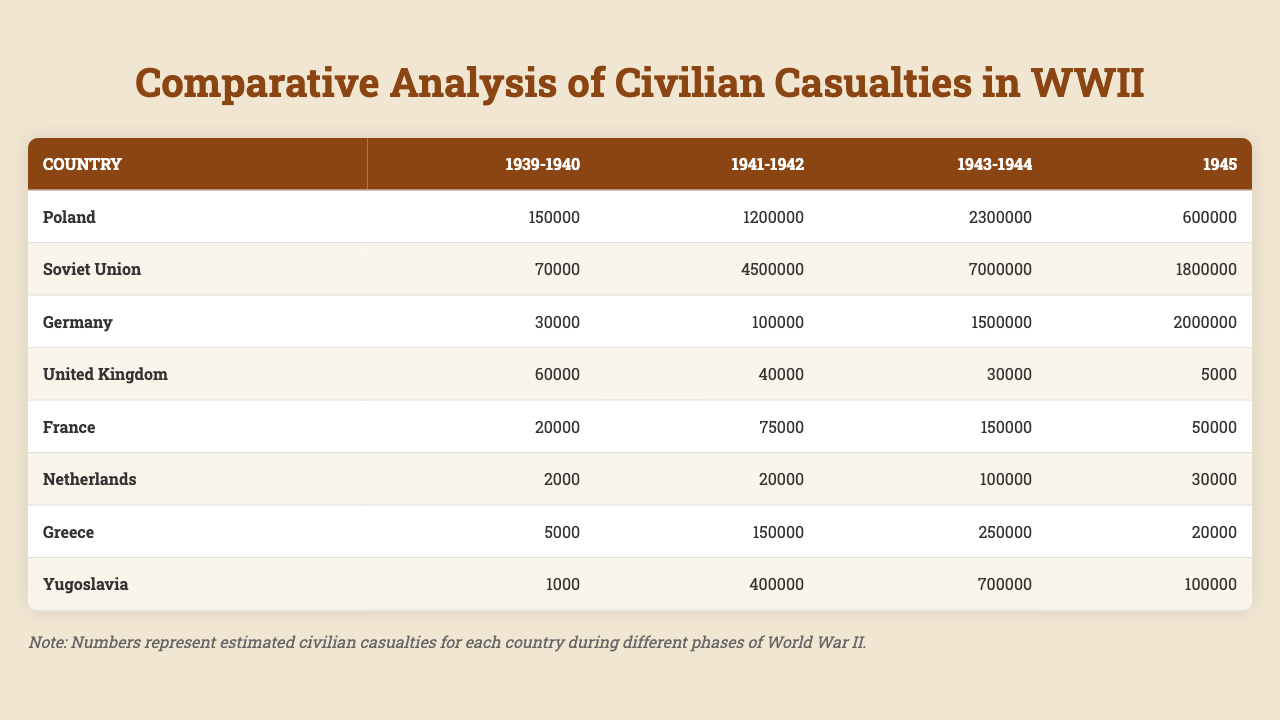What was the total number of civilian casualties in Poland during 1943-1944? The table shows that Poland had 2,300,000 civilian casualties during the period of 1943-1944.
Answer: 2,300,000 Which country experienced the highest civilian casualties in 1941-1942? According to the table, the Soviet Union had 4,500,000 civilian casualties in 1941-1942, which is the highest among the listed countries.
Answer: Soviet Union What is the difference in civilian casualties in Germany between 1945 and 1943-1944? Germany's civilian casualties in 1943-1944 were 1,500,000, and in 1945, they were 2,000,000. The difference is 2,000,000 - 1,500,000 = 500,000.
Answer: 500,000 Did Greece have more civilian casualties in 1941-1942 than France did in 1943-1944? Greece had 150,000 casualties in 1941-1942, while France had 150,000 in 1943-1944, so Greece did not have more casualties, as they are equal.
Answer: No Which country had the least civilian casualties in the period between 1939-1940? The Netherlands had the least civilian casualties in 1939-1940, with a count of 2,000.
Answer: 2,000 What was the total of civilian casualties from 1939 to 1940 across all listed countries? To find the total, we add each country’s casualties from 1939-1940: 150,000 (Poland) + 70,000 (Soviet Union) + 30,000 (Germany) + 60,000 (United Kingdom) + 20,000 (France) + 2,000 (Netherlands) + 5,000 (Greece) + 1,000 (Yugoslavia) = 338,000.
Answer: 338,000 How many civilian casualties did the United Kingdom have in total from 1941 to 1945? In 1941-1942, the UK had 40,000 casualties, 30,000 in 1943-1944, and 5,000 in 1945. Adding these gives 40,000 + 30,000 + 5,000 = 75,000.
Answer: 75,000 Which country had a higher number of civilian casualties in 1945: Poland or the Soviet Union? In 1945, Poland had 600,000 casualties compared to the Soviet Union's 1,800,000. The higher number is from the Soviet Union.
Answer: Soviet Union What was the average number of civilian casualties during the period of 1943-1944 across all listed countries? The civilian casualties in 1943-1944 are: Poland 2,300,000, Soviet Union 7,000,000, Germany 1,500,000, United Kingdom 30,000, France 150,000, Netherlands 100,000, Greece 250,000, and Yugoslavia 700,000. Summing them gives 11,030,000 and dividing by 8 gives an average of 1,379,000.
Answer: 1,379,000 Which country saw a decrease in civilian casualties from 1941-1942 to 1943-1944? According to the data, the United Kingdom decreased from 40,000 in 1941-1942 to 30,000 in 1943-1944, indicating a decrease in casualties.
Answer: Yes 